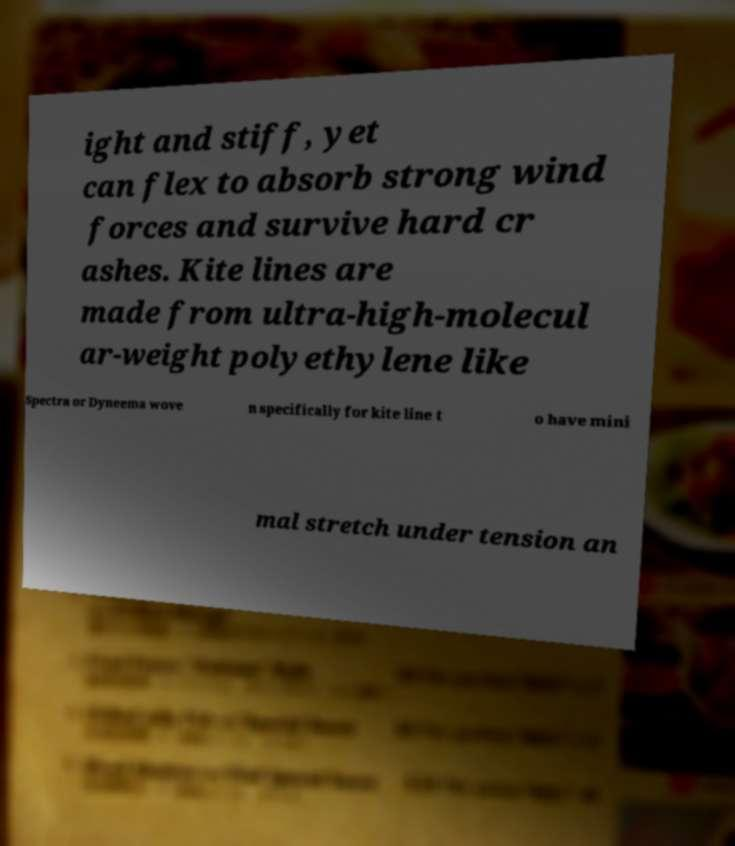Could you extract and type out the text from this image? ight and stiff, yet can flex to absorb strong wind forces and survive hard cr ashes. Kite lines are made from ultra-high-molecul ar-weight polyethylene like Spectra or Dyneema wove n specifically for kite line t o have mini mal stretch under tension an 